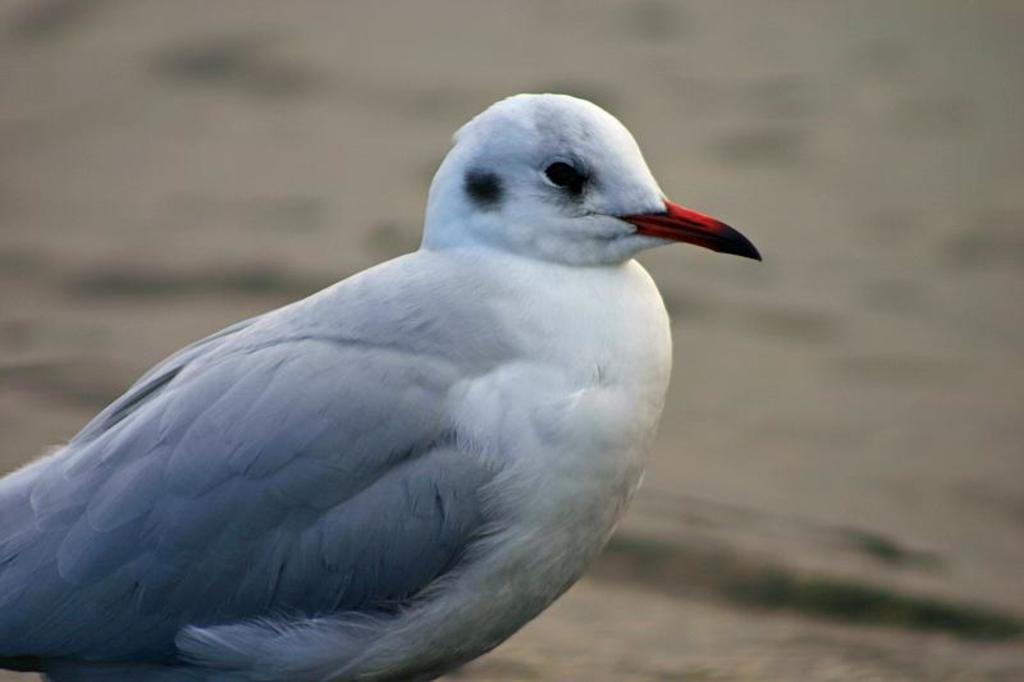Could you give a brief overview of what you see in this image? In this image, we can see a bird. Background there is a blur view. 